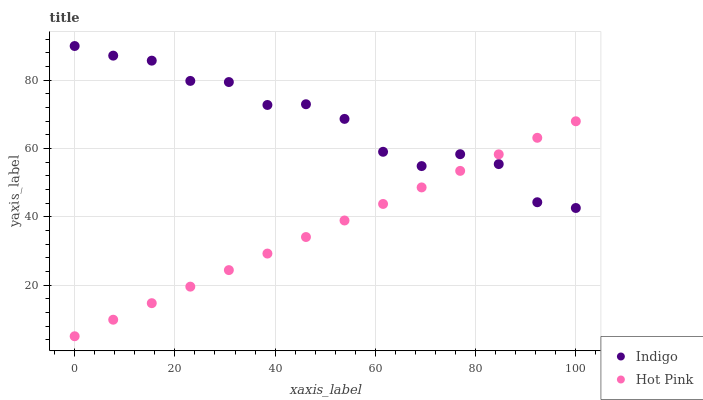Does Hot Pink have the minimum area under the curve?
Answer yes or no. Yes. Does Indigo have the maximum area under the curve?
Answer yes or no. Yes. Does Indigo have the minimum area under the curve?
Answer yes or no. No. Is Hot Pink the smoothest?
Answer yes or no. Yes. Is Indigo the roughest?
Answer yes or no. Yes. Is Indigo the smoothest?
Answer yes or no. No. Does Hot Pink have the lowest value?
Answer yes or no. Yes. Does Indigo have the lowest value?
Answer yes or no. No. Does Indigo have the highest value?
Answer yes or no. Yes. Does Hot Pink intersect Indigo?
Answer yes or no. Yes. Is Hot Pink less than Indigo?
Answer yes or no. No. Is Hot Pink greater than Indigo?
Answer yes or no. No. 